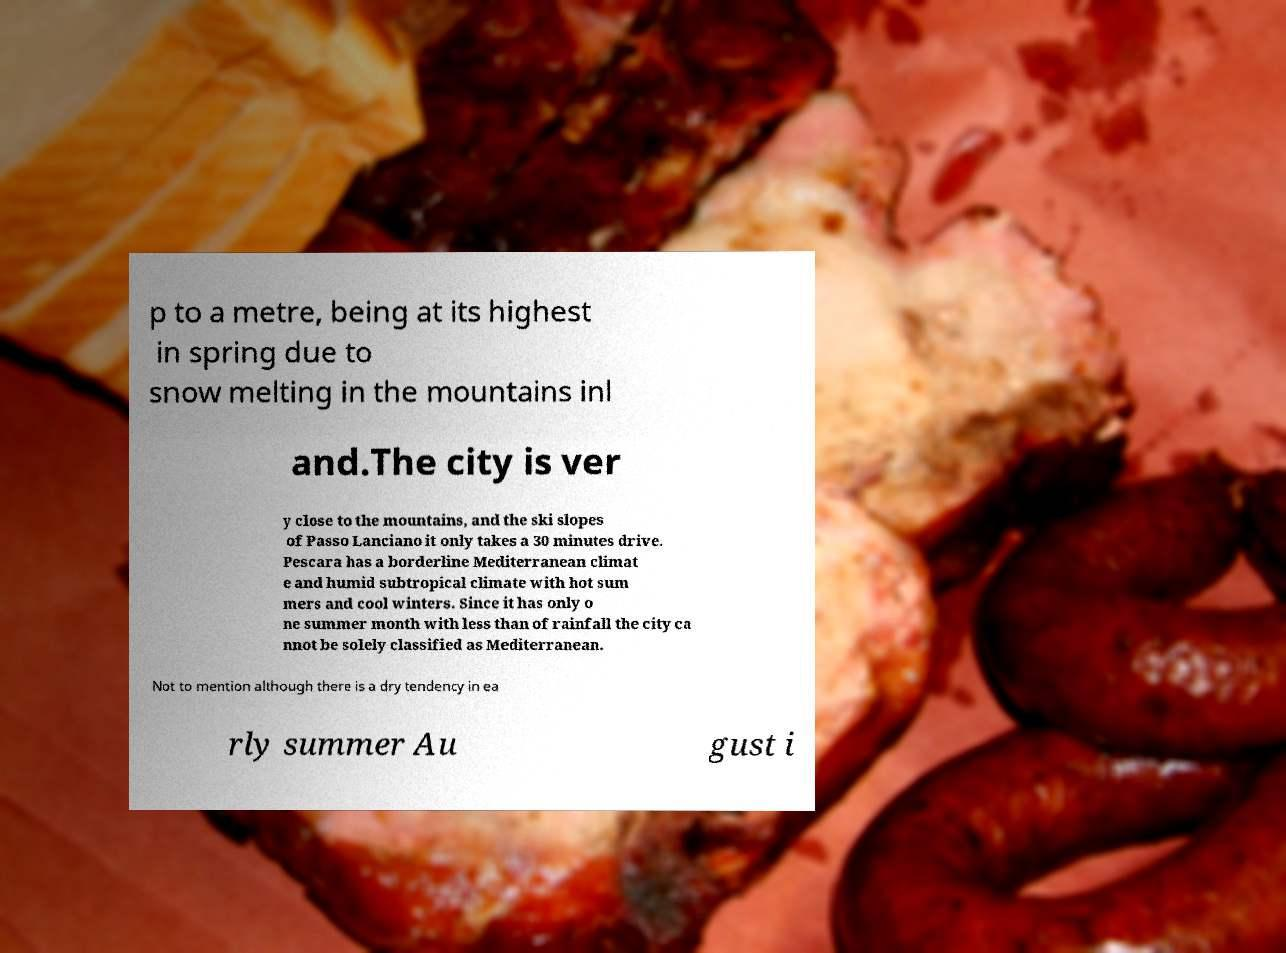There's text embedded in this image that I need extracted. Can you transcribe it verbatim? p to a metre, being at its highest in spring due to snow melting in the mountains inl and.The city is ver y close to the mountains, and the ski slopes of Passo Lanciano it only takes a 30 minutes drive. Pescara has a borderline Mediterranean climat e and humid subtropical climate with hot sum mers and cool winters. Since it has only o ne summer month with less than of rainfall the city ca nnot be solely classified as Mediterranean. Not to mention although there is a dry tendency in ea rly summer Au gust i 